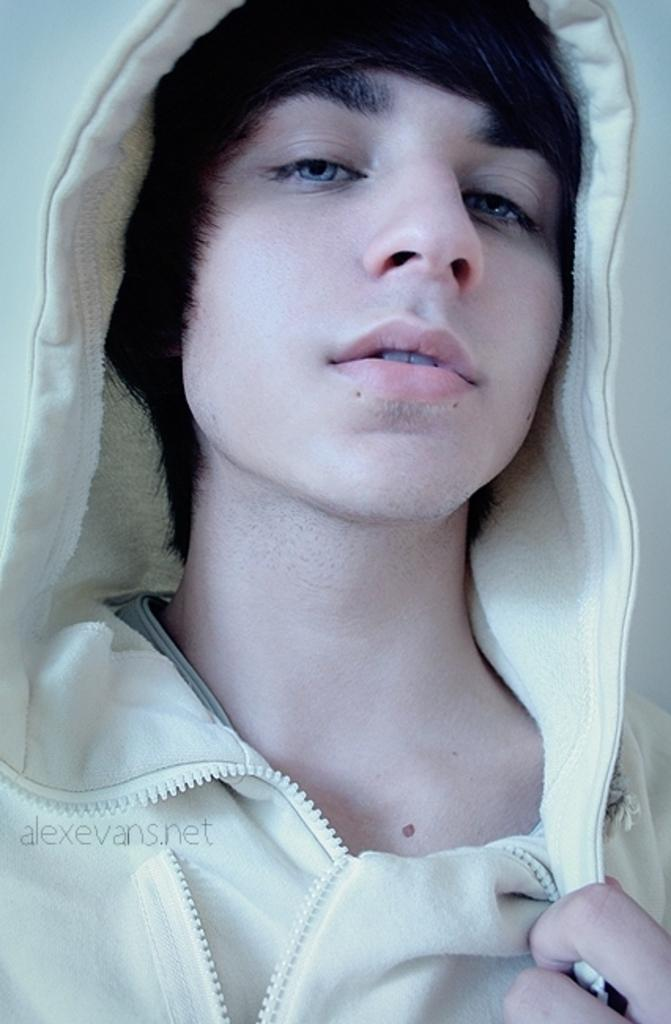What is the main subject of the image? There is a picture of a person in the image. Where is the picture of the person located in the image? The picture of the person is in the middle of the image. What other element can be seen in the image besides the picture of the person? There is a text logo in the image. Where is the text logo located in the image? The text logo is at the bottom left side of the image. Can you see a kitten taking a breath in the image? There is no kitten or any indication of breathing in the image. How many sheep are present in the image? There are no sheep present in the image. 